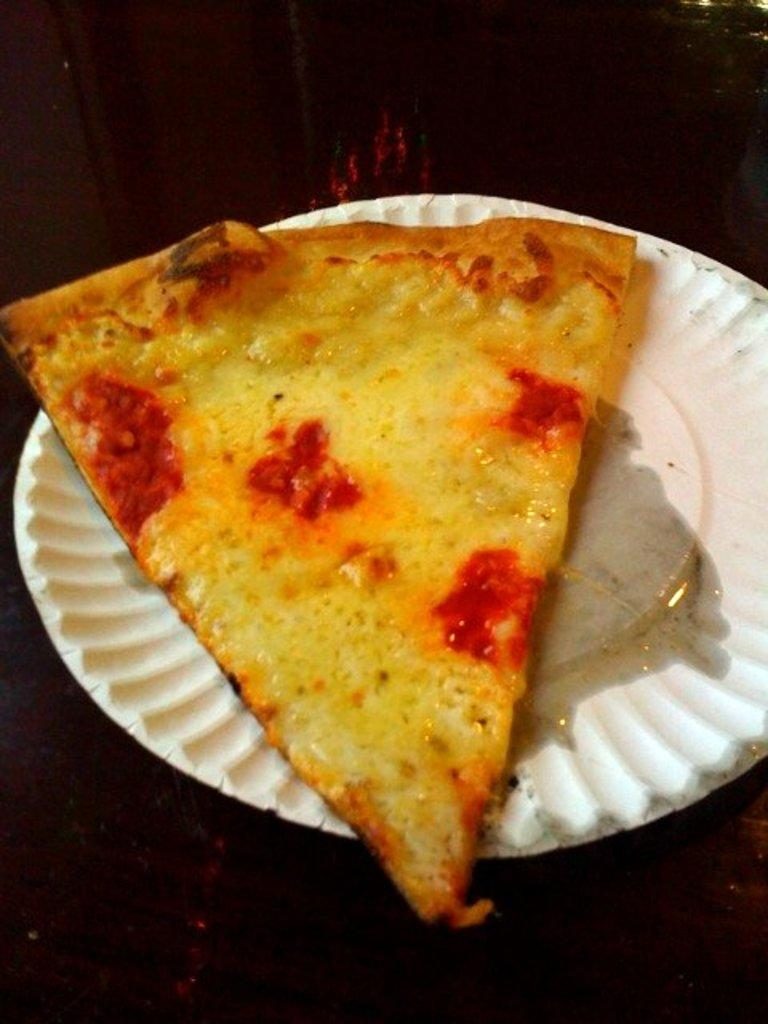What color is the pizza piece in the image? The pizza piece in the image is yellow. What is the pizza piece placed on? The pizza piece is placed on a white plate. How much credit is given for the pizza in the image? There is no mention of credit or any financial aspect related to the pizza in the image. 